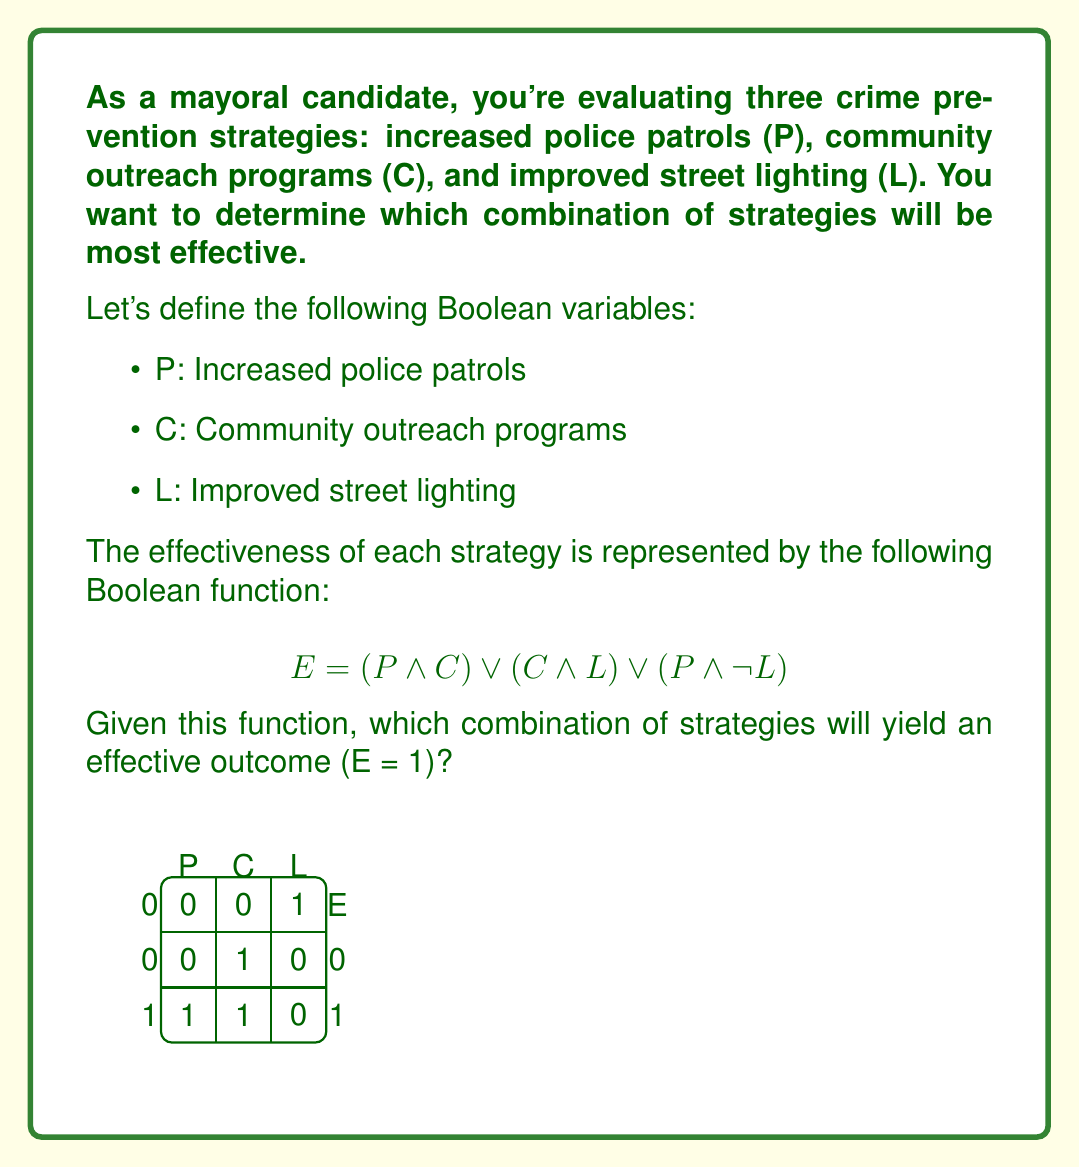Help me with this question. To solve this problem, we need to evaluate the Boolean function for different combinations of P, C, and L. Let's break it down step-by-step:

1) First, let's expand the Boolean function:
   $$E = (P \land C) \lor (C \land L) \lor (P \land \neg L)$$

2) We need to find the combinations where E = 1. Let's evaluate each term:

   a) $(P \land C)$: This is true when both P and C are true (1).
   b) $(C \land L)$: This is true when both C and L are true (1).
   c) $(P \land \neg L)$: This is true when P is true (1) and L is false (0).

3) Now, let's consider all possible combinations:

   - P = 0, C = 0, L = 0: E = (0 ∧ 0) ∨ (0 ∧ 0) ∨ (0 ∧ 1) = 0 ∨ 0 ∨ 0 = 0
   - P = 0, C = 0, L = 1: E = (0 ∧ 0) ∨ (0 ∧ 1) ∨ (0 ∧ 0) = 0 ∨ 0 ∨ 0 = 0
   - P = 0, C = 1, L = 0: E = (0 ∧ 1) ∨ (1 ∧ 0) ∨ (0 ∧ 1) = 0 ∨ 0 ∨ 0 = 0
   - P = 0, C = 1, L = 1: E = (0 ∧ 1) ∨ (1 ∧ 1) ∨ (0 ∧ 0) = 0 ∨ 1 ∨ 0 = 1
   - P = 1, C = 0, L = 0: E = (1 ∧ 0) ∨ (0 ∧ 0) ∨ (1 ∧ 1) = 0 ∨ 0 ∨ 1 = 1
   - P = 1, C = 0, L = 1: E = (1 ∧ 0) ∨ (0 ∧ 1) ∨ (1 ∧ 0) = 0 ∨ 0 ∨ 0 = 0
   - P = 1, C = 1, L = 0: E = (1 ∧ 1) ∨ (1 ∧ 0) ∨ (1 ∧ 1) = 1 ∨ 0 ∨ 1 = 1
   - P = 1, C = 1, L = 1: E = (1 ∧ 1) ∨ (1 ∧ 1) ∨ (1 ∧ 0) = 1 ∨ 1 ∨ 0 = 1

4) From this evaluation, we can see that E = 1 (effective) when:
   - P = 0, C = 1, L = 1
   - P = 1, C = 0, L = 0
   - P = 1, C = 1, L = 0
   - P = 1, C = 1, L = 1

These results are also reflected in the truth table provided in the question.
Answer: (P = 0, C = 1, L = 1), (P = 1, C = 0, L = 0), (P = 1, C = 1, L = 0), (P = 1, C = 1, L = 1) 